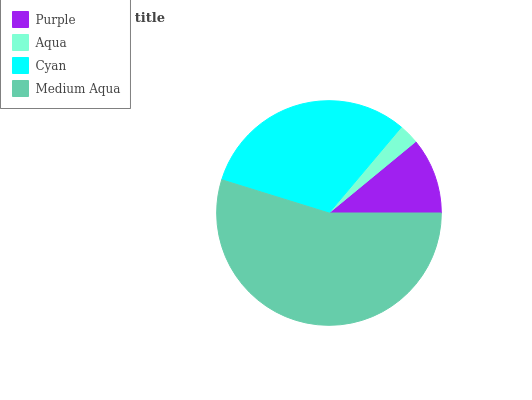Is Aqua the minimum?
Answer yes or no. Yes. Is Medium Aqua the maximum?
Answer yes or no. Yes. Is Cyan the minimum?
Answer yes or no. No. Is Cyan the maximum?
Answer yes or no. No. Is Cyan greater than Aqua?
Answer yes or no. Yes. Is Aqua less than Cyan?
Answer yes or no. Yes. Is Aqua greater than Cyan?
Answer yes or no. No. Is Cyan less than Aqua?
Answer yes or no. No. Is Cyan the high median?
Answer yes or no. Yes. Is Purple the low median?
Answer yes or no. Yes. Is Medium Aqua the high median?
Answer yes or no. No. Is Cyan the low median?
Answer yes or no. No. 